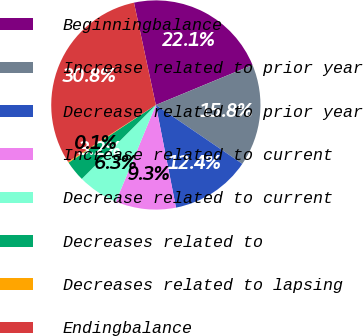<chart> <loc_0><loc_0><loc_500><loc_500><pie_chart><fcel>Beginningbalance<fcel>Increase related to prior year<fcel>Decrease related to prior year<fcel>Increase related to current<fcel>Decrease related to current<fcel>Decreases related to<fcel>Decreases related to lapsing<fcel>Endingbalance<nl><fcel>22.11%<fcel>15.76%<fcel>12.4%<fcel>9.33%<fcel>6.27%<fcel>3.2%<fcel>0.14%<fcel>30.8%<nl></chart> 